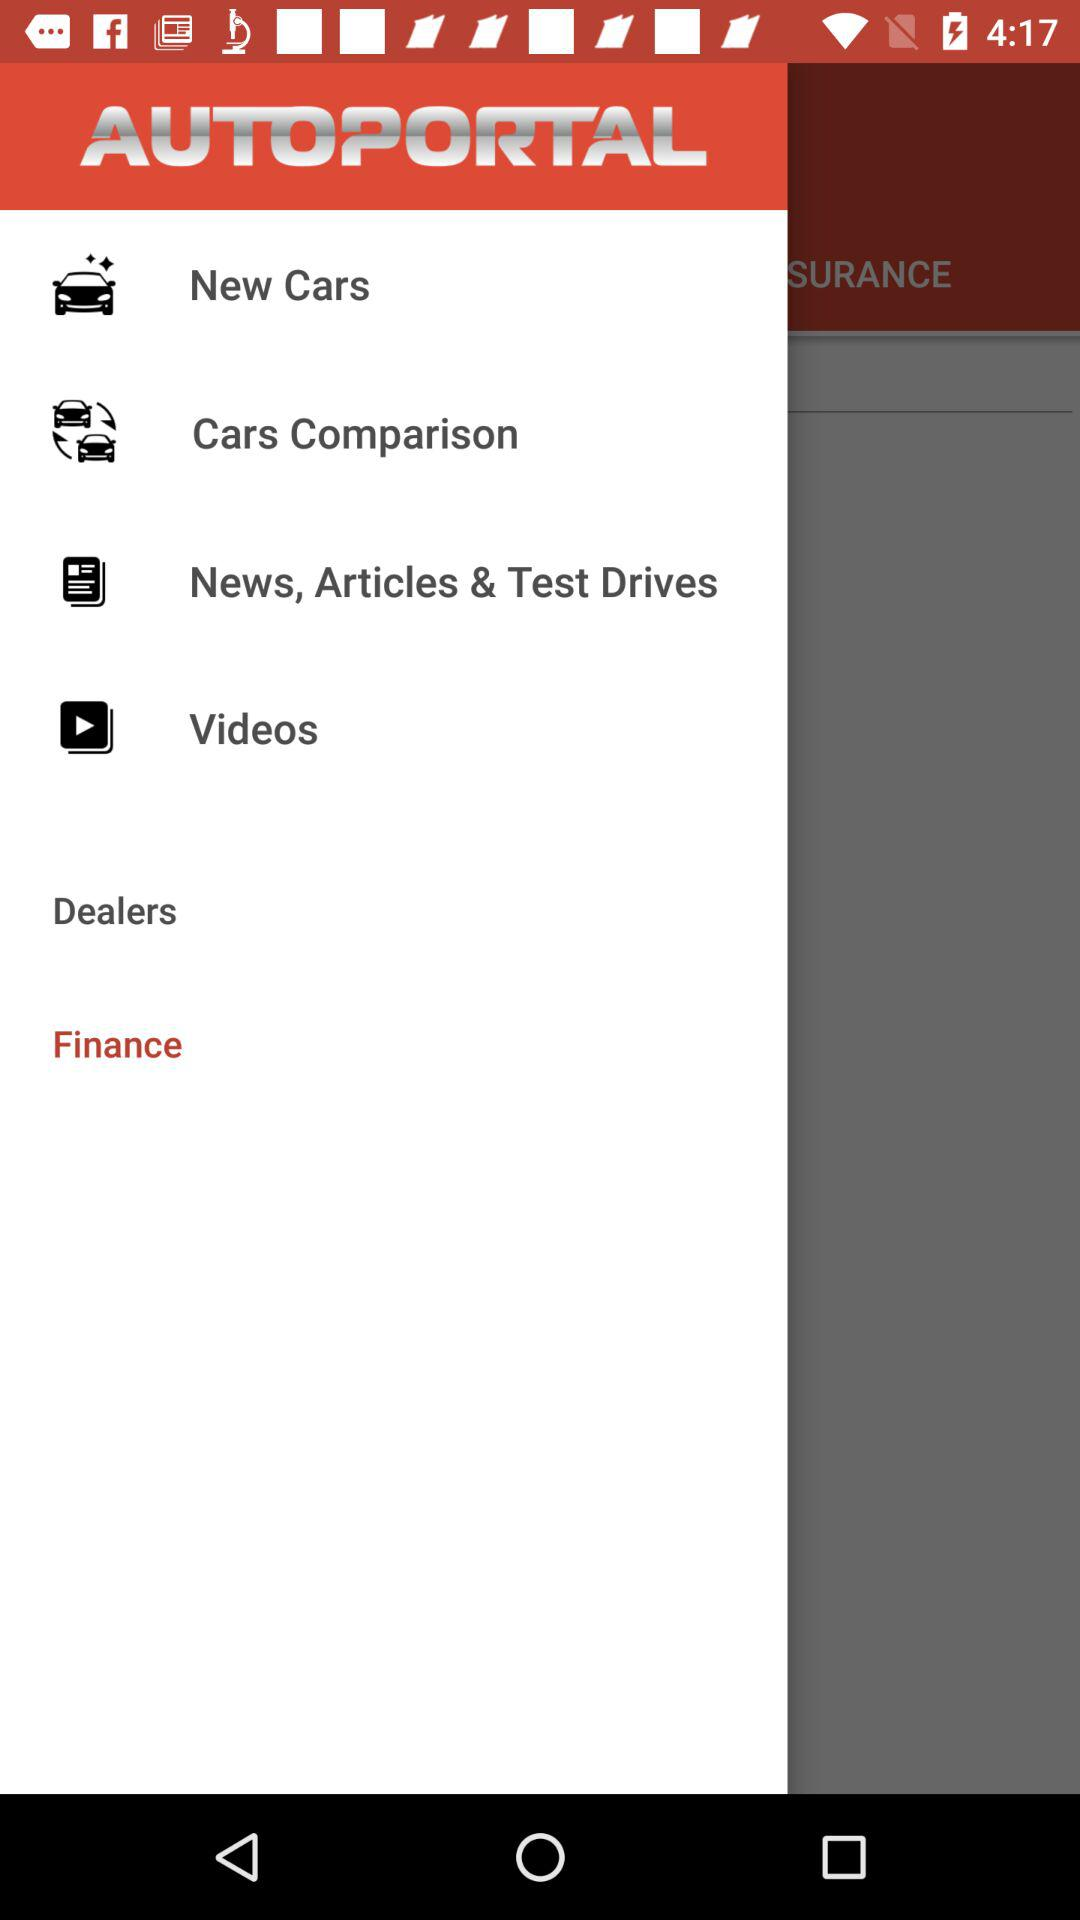What is the application name? The application name is "AUTOPORTAL". 